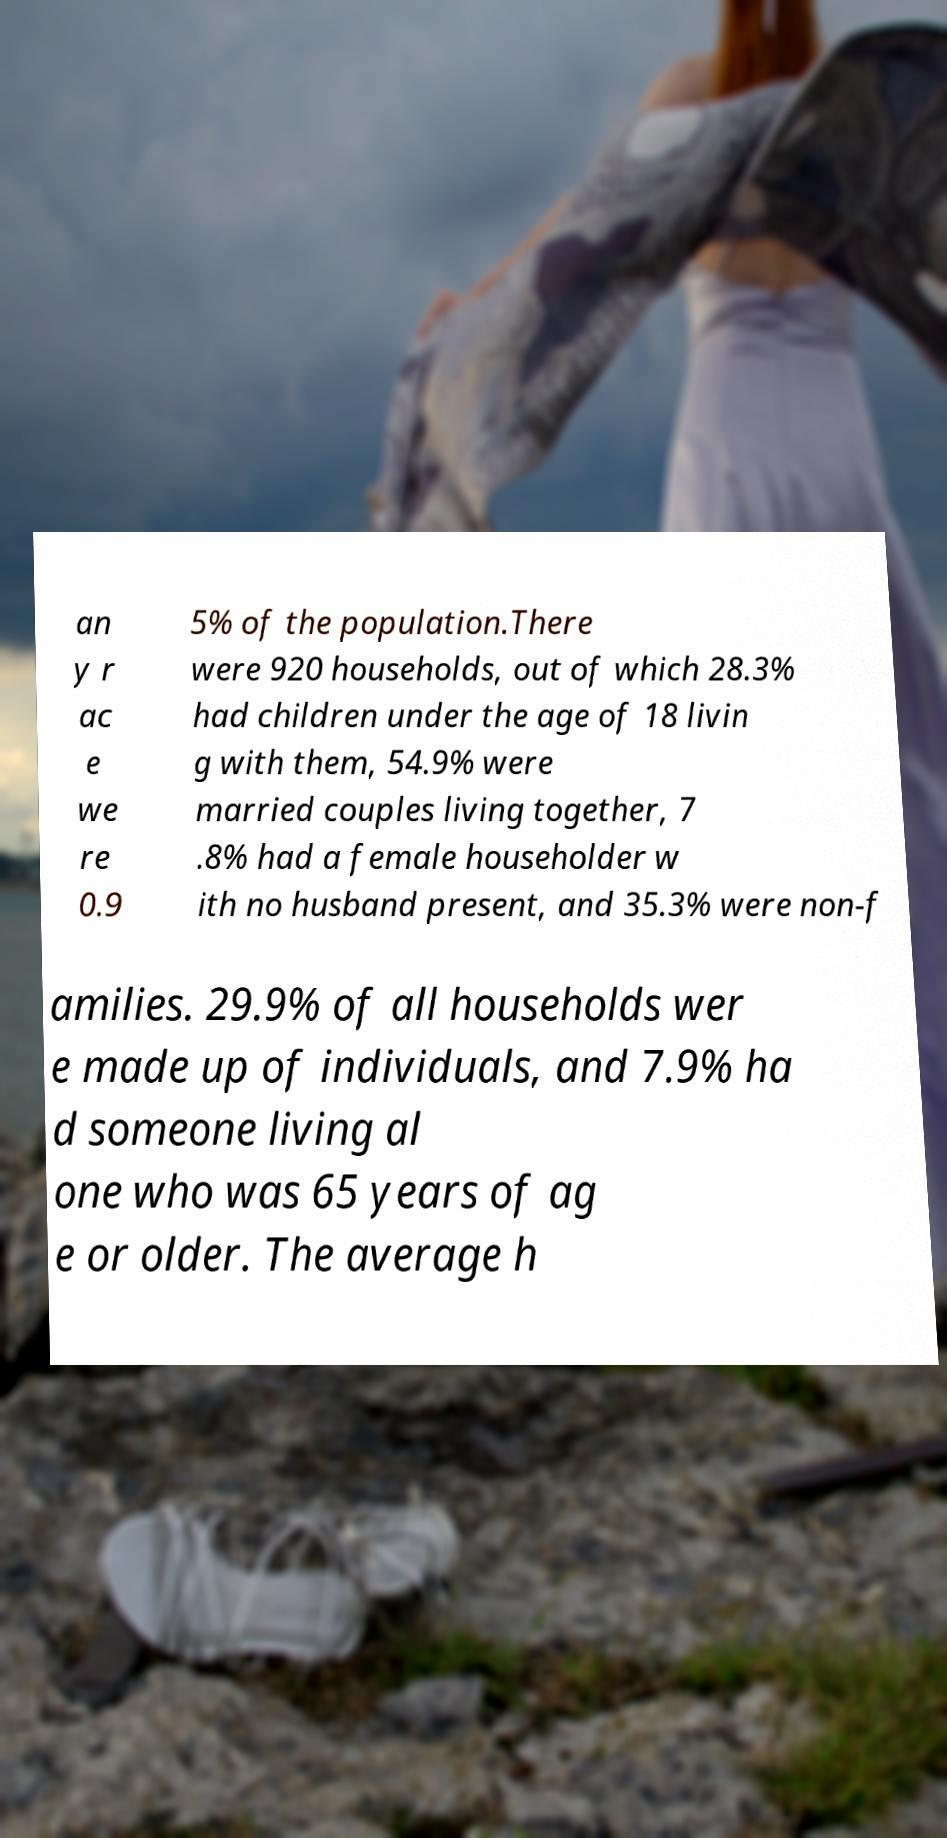Can you read and provide the text displayed in the image?This photo seems to have some interesting text. Can you extract and type it out for me? an y r ac e we re 0.9 5% of the population.There were 920 households, out of which 28.3% had children under the age of 18 livin g with them, 54.9% were married couples living together, 7 .8% had a female householder w ith no husband present, and 35.3% were non-f amilies. 29.9% of all households wer e made up of individuals, and 7.9% ha d someone living al one who was 65 years of ag e or older. The average h 